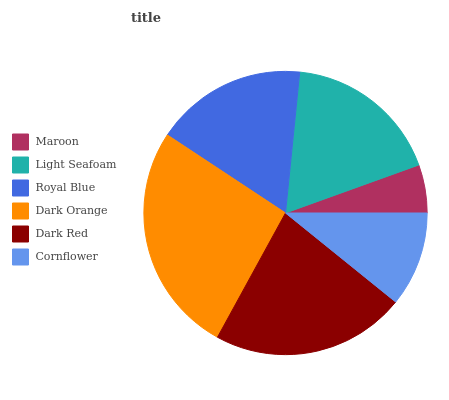Is Maroon the minimum?
Answer yes or no. Yes. Is Dark Orange the maximum?
Answer yes or no. Yes. Is Light Seafoam the minimum?
Answer yes or no. No. Is Light Seafoam the maximum?
Answer yes or no. No. Is Light Seafoam greater than Maroon?
Answer yes or no. Yes. Is Maroon less than Light Seafoam?
Answer yes or no. Yes. Is Maroon greater than Light Seafoam?
Answer yes or no. No. Is Light Seafoam less than Maroon?
Answer yes or no. No. Is Light Seafoam the high median?
Answer yes or no. Yes. Is Royal Blue the low median?
Answer yes or no. Yes. Is Dark Orange the high median?
Answer yes or no. No. Is Cornflower the low median?
Answer yes or no. No. 